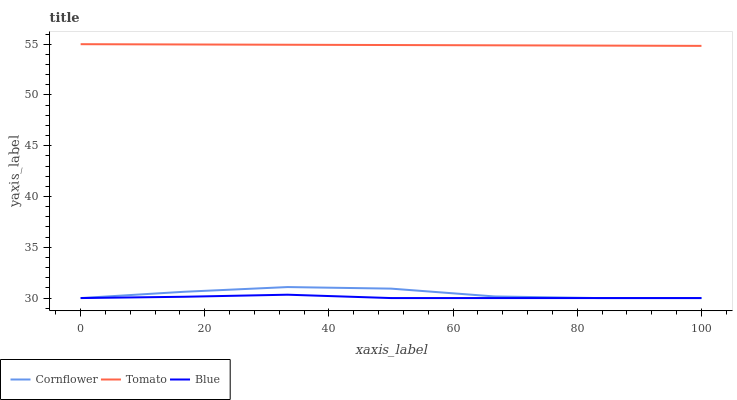Does Blue have the minimum area under the curve?
Answer yes or no. Yes. Does Tomato have the maximum area under the curve?
Answer yes or no. Yes. Does Cornflower have the minimum area under the curve?
Answer yes or no. No. Does Cornflower have the maximum area under the curve?
Answer yes or no. No. Is Tomato the smoothest?
Answer yes or no. Yes. Is Cornflower the roughest?
Answer yes or no. Yes. Is Blue the smoothest?
Answer yes or no. No. Is Blue the roughest?
Answer yes or no. No. Does Cornflower have the lowest value?
Answer yes or no. Yes. Does Tomato have the highest value?
Answer yes or no. Yes. Does Cornflower have the highest value?
Answer yes or no. No. Is Cornflower less than Tomato?
Answer yes or no. Yes. Is Tomato greater than Cornflower?
Answer yes or no. Yes. Does Cornflower intersect Blue?
Answer yes or no. Yes. Is Cornflower less than Blue?
Answer yes or no. No. Is Cornflower greater than Blue?
Answer yes or no. No. Does Cornflower intersect Tomato?
Answer yes or no. No. 